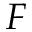Convert formula to latex. <formula><loc_0><loc_0><loc_500><loc_500>F</formula> 